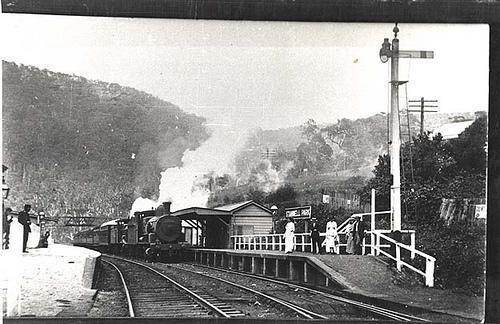How many chairs are pictured?
Give a very brief answer. 0. 